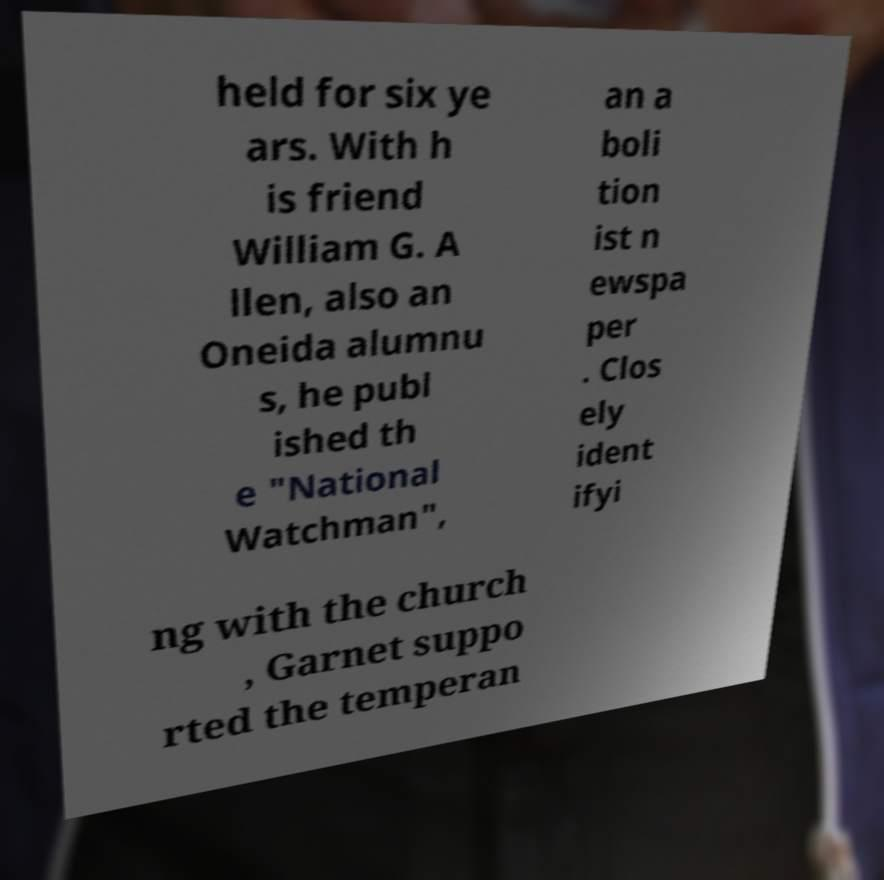Can you accurately transcribe the text from the provided image for me? held for six ye ars. With h is friend William G. A llen, also an Oneida alumnu s, he publ ished th e "National Watchman", an a boli tion ist n ewspa per . Clos ely ident ifyi ng with the church , Garnet suppo rted the temperan 